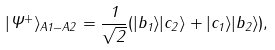Convert formula to latex. <formula><loc_0><loc_0><loc_500><loc_500>| \Psi ^ { + } \rangle _ { A 1 - A 2 } = \frac { 1 } { \sqrt { 2 } } ( | b _ { 1 } \rangle | c _ { 2 } \rangle + | c _ { 1 } \rangle | b _ { 2 } \rangle ) ,</formula> 